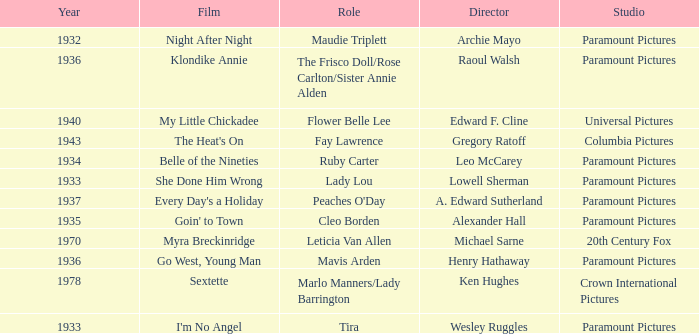What is the Year of the Film Klondike Annie? 1936.0. Write the full table. {'header': ['Year', 'Film', 'Role', 'Director', 'Studio'], 'rows': [['1932', 'Night After Night', 'Maudie Triplett', 'Archie Mayo', 'Paramount Pictures'], ['1936', 'Klondike Annie', 'The Frisco Doll/Rose Carlton/Sister Annie Alden', 'Raoul Walsh', 'Paramount Pictures'], ['1940', 'My Little Chickadee', 'Flower Belle Lee', 'Edward F. Cline', 'Universal Pictures'], ['1943', "The Heat's On", 'Fay Lawrence', 'Gregory Ratoff', 'Columbia Pictures'], ['1934', 'Belle of the Nineties', 'Ruby Carter', 'Leo McCarey', 'Paramount Pictures'], ['1933', 'She Done Him Wrong', 'Lady Lou', 'Lowell Sherman', 'Paramount Pictures'], ['1937', "Every Day's a Holiday", "Peaches O'Day", 'A. Edward Sutherland', 'Paramount Pictures'], ['1935', "Goin' to Town", 'Cleo Borden', 'Alexander Hall', 'Paramount Pictures'], ['1970', 'Myra Breckinridge', 'Leticia Van Allen', 'Michael Sarne', '20th Century Fox'], ['1936', 'Go West, Young Man', 'Mavis Arden', 'Henry Hathaway', 'Paramount Pictures'], ['1978', 'Sextette', 'Marlo Manners/Lady Barrington', 'Ken Hughes', 'Crown International Pictures'], ['1933', "I'm No Angel", 'Tira', 'Wesley Ruggles', 'Paramount Pictures']]} 